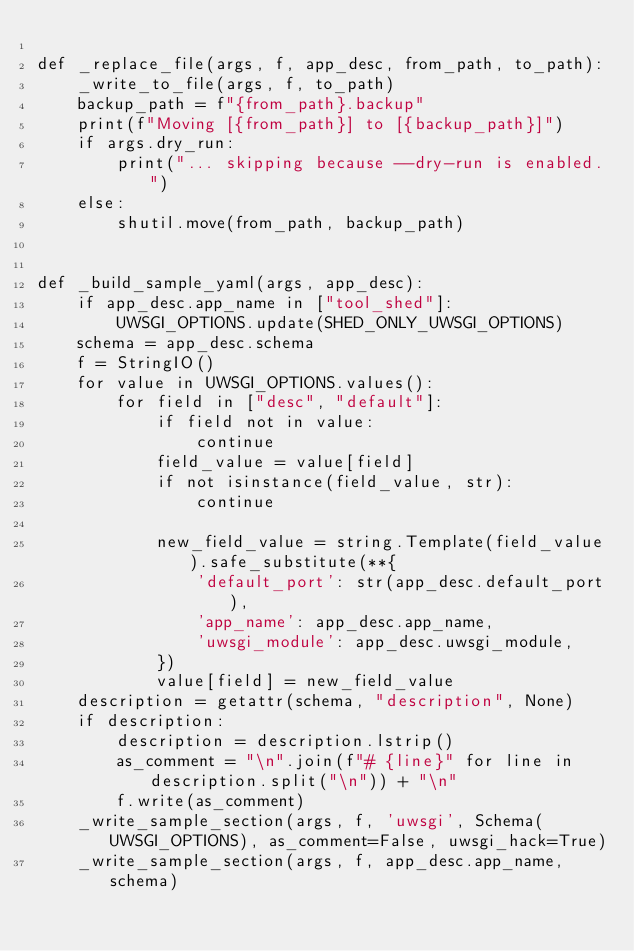Convert code to text. <code><loc_0><loc_0><loc_500><loc_500><_Python_>
def _replace_file(args, f, app_desc, from_path, to_path):
    _write_to_file(args, f, to_path)
    backup_path = f"{from_path}.backup"
    print(f"Moving [{from_path}] to [{backup_path}]")
    if args.dry_run:
        print("... skipping because --dry-run is enabled.")
    else:
        shutil.move(from_path, backup_path)


def _build_sample_yaml(args, app_desc):
    if app_desc.app_name in ["tool_shed"]:
        UWSGI_OPTIONS.update(SHED_ONLY_UWSGI_OPTIONS)
    schema = app_desc.schema
    f = StringIO()
    for value in UWSGI_OPTIONS.values():
        for field in ["desc", "default"]:
            if field not in value:
                continue
            field_value = value[field]
            if not isinstance(field_value, str):
                continue

            new_field_value = string.Template(field_value).safe_substitute(**{
                'default_port': str(app_desc.default_port),
                'app_name': app_desc.app_name,
                'uwsgi_module': app_desc.uwsgi_module,
            })
            value[field] = new_field_value
    description = getattr(schema, "description", None)
    if description:
        description = description.lstrip()
        as_comment = "\n".join(f"# {line}" for line in description.split("\n")) + "\n"
        f.write(as_comment)
    _write_sample_section(args, f, 'uwsgi', Schema(UWSGI_OPTIONS), as_comment=False, uwsgi_hack=True)
    _write_sample_section(args, f, app_desc.app_name, schema)</code> 